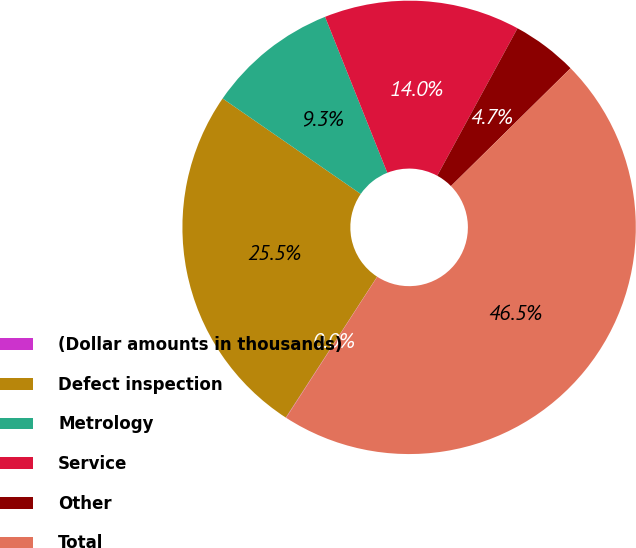<chart> <loc_0><loc_0><loc_500><loc_500><pie_chart><fcel>(Dollar amounts in thousands)<fcel>Defect inspection<fcel>Metrology<fcel>Service<fcel>Other<fcel>Total<nl><fcel>0.03%<fcel>25.47%<fcel>9.33%<fcel>13.98%<fcel>4.68%<fcel>46.51%<nl></chart> 